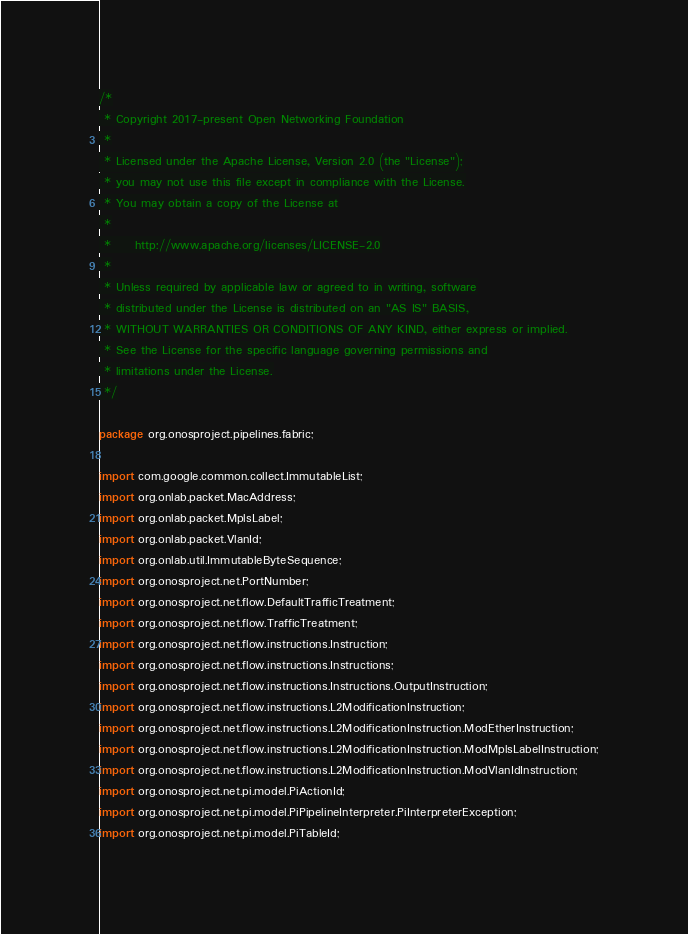Convert code to text. <code><loc_0><loc_0><loc_500><loc_500><_Java_>/*
 * Copyright 2017-present Open Networking Foundation
 *
 * Licensed under the Apache License, Version 2.0 (the "License");
 * you may not use this file except in compliance with the License.
 * You may obtain a copy of the License at
 *
 *     http://www.apache.org/licenses/LICENSE-2.0
 *
 * Unless required by applicable law or agreed to in writing, software
 * distributed under the License is distributed on an "AS IS" BASIS,
 * WITHOUT WARRANTIES OR CONDITIONS OF ANY KIND, either express or implied.
 * See the License for the specific language governing permissions and
 * limitations under the License.
 */

package org.onosproject.pipelines.fabric;

import com.google.common.collect.ImmutableList;
import org.onlab.packet.MacAddress;
import org.onlab.packet.MplsLabel;
import org.onlab.packet.VlanId;
import org.onlab.util.ImmutableByteSequence;
import org.onosproject.net.PortNumber;
import org.onosproject.net.flow.DefaultTrafficTreatment;
import org.onosproject.net.flow.TrafficTreatment;
import org.onosproject.net.flow.instructions.Instruction;
import org.onosproject.net.flow.instructions.Instructions;
import org.onosproject.net.flow.instructions.Instructions.OutputInstruction;
import org.onosproject.net.flow.instructions.L2ModificationInstruction;
import org.onosproject.net.flow.instructions.L2ModificationInstruction.ModEtherInstruction;
import org.onosproject.net.flow.instructions.L2ModificationInstruction.ModMplsLabelInstruction;
import org.onosproject.net.flow.instructions.L2ModificationInstruction.ModVlanIdInstruction;
import org.onosproject.net.pi.model.PiActionId;
import org.onosproject.net.pi.model.PiPipelineInterpreter.PiInterpreterException;
import org.onosproject.net.pi.model.PiTableId;</code> 